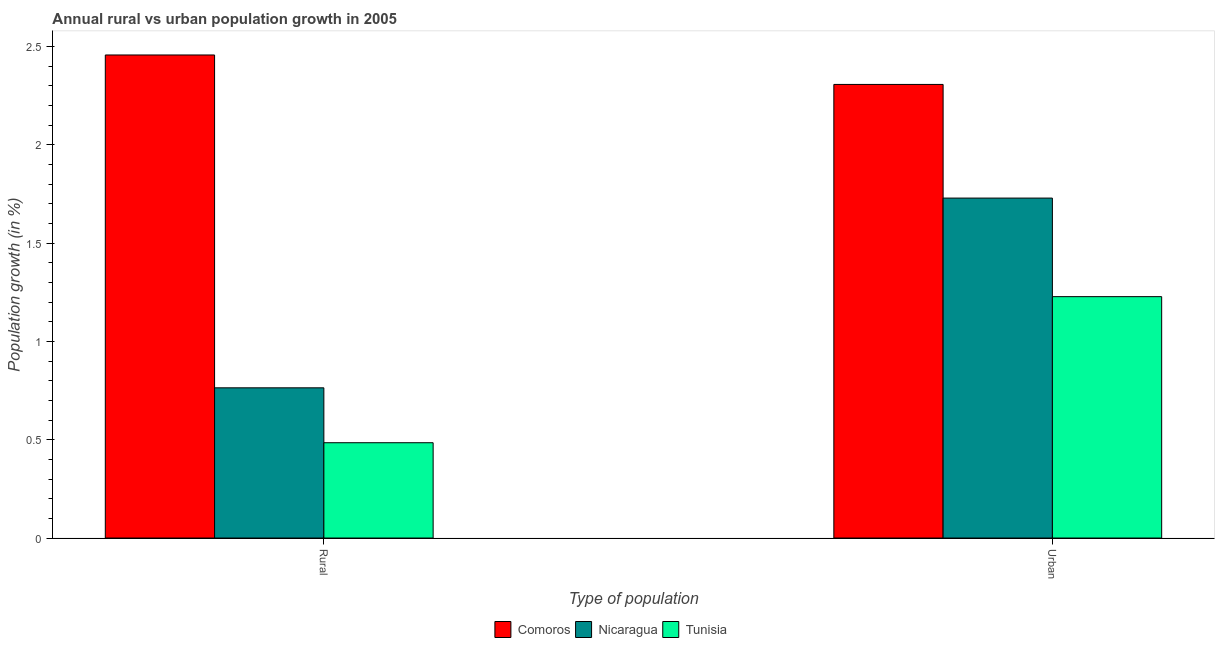How many different coloured bars are there?
Offer a terse response. 3. How many groups of bars are there?
Offer a very short reply. 2. Are the number of bars per tick equal to the number of legend labels?
Keep it short and to the point. Yes. Are the number of bars on each tick of the X-axis equal?
Keep it short and to the point. Yes. How many bars are there on the 1st tick from the left?
Offer a very short reply. 3. How many bars are there on the 1st tick from the right?
Provide a succinct answer. 3. What is the label of the 1st group of bars from the left?
Provide a succinct answer. Rural. What is the urban population growth in Nicaragua?
Make the answer very short. 1.73. Across all countries, what is the maximum urban population growth?
Your answer should be compact. 2.31. Across all countries, what is the minimum urban population growth?
Make the answer very short. 1.23. In which country was the rural population growth maximum?
Provide a short and direct response. Comoros. In which country was the urban population growth minimum?
Offer a terse response. Tunisia. What is the total urban population growth in the graph?
Your response must be concise. 5.26. What is the difference between the rural population growth in Comoros and that in Tunisia?
Provide a succinct answer. 1.97. What is the difference between the urban population growth in Comoros and the rural population growth in Tunisia?
Ensure brevity in your answer.  1.82. What is the average urban population growth per country?
Your answer should be very brief. 1.75. What is the difference between the rural population growth and urban population growth in Nicaragua?
Your response must be concise. -0.97. What is the ratio of the urban population growth in Comoros to that in Nicaragua?
Offer a very short reply. 1.33. Is the rural population growth in Nicaragua less than that in Tunisia?
Provide a succinct answer. No. What does the 2nd bar from the left in Urban  represents?
Offer a very short reply. Nicaragua. What does the 2nd bar from the right in Rural represents?
Your response must be concise. Nicaragua. How many bars are there?
Provide a succinct answer. 6. Are all the bars in the graph horizontal?
Make the answer very short. No. How many countries are there in the graph?
Your answer should be compact. 3. Does the graph contain grids?
Offer a very short reply. No. How many legend labels are there?
Your answer should be compact. 3. How are the legend labels stacked?
Offer a terse response. Horizontal. What is the title of the graph?
Provide a succinct answer. Annual rural vs urban population growth in 2005. What is the label or title of the X-axis?
Offer a very short reply. Type of population. What is the label or title of the Y-axis?
Your response must be concise. Population growth (in %). What is the Population growth (in %) in Comoros in Rural?
Your answer should be very brief. 2.46. What is the Population growth (in %) of Nicaragua in Rural?
Keep it short and to the point. 0.76. What is the Population growth (in %) in Tunisia in Rural?
Your answer should be compact. 0.48. What is the Population growth (in %) in Comoros in Urban ?
Make the answer very short. 2.31. What is the Population growth (in %) of Nicaragua in Urban ?
Offer a terse response. 1.73. What is the Population growth (in %) in Tunisia in Urban ?
Keep it short and to the point. 1.23. Across all Type of population, what is the maximum Population growth (in %) of Comoros?
Keep it short and to the point. 2.46. Across all Type of population, what is the maximum Population growth (in %) in Nicaragua?
Offer a terse response. 1.73. Across all Type of population, what is the maximum Population growth (in %) in Tunisia?
Your answer should be compact. 1.23. Across all Type of population, what is the minimum Population growth (in %) of Comoros?
Your answer should be very brief. 2.31. Across all Type of population, what is the minimum Population growth (in %) of Nicaragua?
Ensure brevity in your answer.  0.76. Across all Type of population, what is the minimum Population growth (in %) of Tunisia?
Offer a very short reply. 0.48. What is the total Population growth (in %) in Comoros in the graph?
Your answer should be very brief. 4.76. What is the total Population growth (in %) of Nicaragua in the graph?
Offer a very short reply. 2.49. What is the total Population growth (in %) in Tunisia in the graph?
Your response must be concise. 1.71. What is the difference between the Population growth (in %) of Comoros in Rural and that in Urban ?
Keep it short and to the point. 0.15. What is the difference between the Population growth (in %) of Nicaragua in Rural and that in Urban ?
Provide a short and direct response. -0.97. What is the difference between the Population growth (in %) in Tunisia in Rural and that in Urban ?
Offer a very short reply. -0.74. What is the difference between the Population growth (in %) of Comoros in Rural and the Population growth (in %) of Nicaragua in Urban?
Provide a succinct answer. 0.73. What is the difference between the Population growth (in %) in Comoros in Rural and the Population growth (in %) in Tunisia in Urban?
Provide a succinct answer. 1.23. What is the difference between the Population growth (in %) in Nicaragua in Rural and the Population growth (in %) in Tunisia in Urban?
Your answer should be very brief. -0.46. What is the average Population growth (in %) in Comoros per Type of population?
Offer a terse response. 2.38. What is the average Population growth (in %) in Nicaragua per Type of population?
Your answer should be compact. 1.25. What is the average Population growth (in %) in Tunisia per Type of population?
Keep it short and to the point. 0.86. What is the difference between the Population growth (in %) of Comoros and Population growth (in %) of Nicaragua in Rural?
Your answer should be compact. 1.69. What is the difference between the Population growth (in %) in Comoros and Population growth (in %) in Tunisia in Rural?
Give a very brief answer. 1.97. What is the difference between the Population growth (in %) of Nicaragua and Population growth (in %) of Tunisia in Rural?
Offer a very short reply. 0.28. What is the difference between the Population growth (in %) of Comoros and Population growth (in %) of Nicaragua in Urban ?
Ensure brevity in your answer.  0.58. What is the difference between the Population growth (in %) of Comoros and Population growth (in %) of Tunisia in Urban ?
Make the answer very short. 1.08. What is the difference between the Population growth (in %) of Nicaragua and Population growth (in %) of Tunisia in Urban ?
Your answer should be very brief. 0.5. What is the ratio of the Population growth (in %) of Comoros in Rural to that in Urban ?
Offer a very short reply. 1.06. What is the ratio of the Population growth (in %) of Nicaragua in Rural to that in Urban ?
Your answer should be compact. 0.44. What is the ratio of the Population growth (in %) of Tunisia in Rural to that in Urban ?
Your answer should be very brief. 0.39. What is the difference between the highest and the second highest Population growth (in %) of Comoros?
Make the answer very short. 0.15. What is the difference between the highest and the second highest Population growth (in %) of Nicaragua?
Your answer should be compact. 0.97. What is the difference between the highest and the second highest Population growth (in %) of Tunisia?
Keep it short and to the point. 0.74. What is the difference between the highest and the lowest Population growth (in %) of Comoros?
Provide a succinct answer. 0.15. What is the difference between the highest and the lowest Population growth (in %) of Nicaragua?
Provide a succinct answer. 0.97. What is the difference between the highest and the lowest Population growth (in %) in Tunisia?
Your answer should be compact. 0.74. 